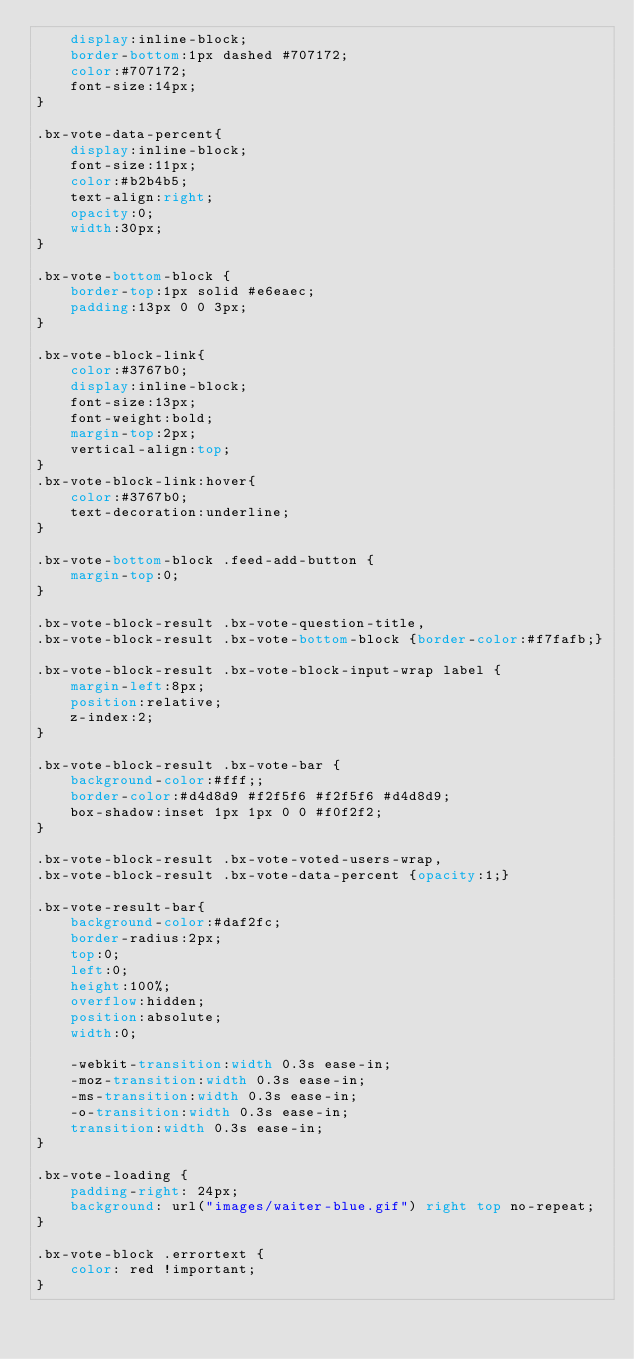<code> <loc_0><loc_0><loc_500><loc_500><_CSS_>	display:inline-block;
	border-bottom:1px dashed #707172;
	color:#707172;
	font-size:14px;
}

.bx-vote-data-percent{
	display:inline-block;
	font-size:11px;
	color:#b2b4b5;
	text-align:right;
	opacity:0;
	width:30px;
}

.bx-vote-bottom-block {
	border-top:1px solid #e6eaec;
	padding:13px 0 0 3px;
}

.bx-vote-block-link{
	color:#3767b0;
	display:inline-block;
	font-size:13px;
	font-weight:bold;
	margin-top:2px;
	vertical-align:top;
}
.bx-vote-block-link:hover{
	color:#3767b0;
	text-decoration:underline;
}

.bx-vote-bottom-block .feed-add-button {
	margin-top:0;
}

.bx-vote-block-result .bx-vote-question-title,
.bx-vote-block-result .bx-vote-bottom-block {border-color:#f7fafb;}

.bx-vote-block-result .bx-vote-block-input-wrap label {
	margin-left:8px;
	position:relative;
	z-index:2;
}

.bx-vote-block-result .bx-vote-bar {
	background-color:#fff;;
	border-color:#d4d8d9 #f2f5f6 #f2f5f6 #d4d8d9;
	box-shadow:inset 1px 1px 0 0 #f0f2f2;
}

.bx-vote-block-result .bx-vote-voted-users-wrap,
.bx-vote-block-result .bx-vote-data-percent {opacity:1;}

.bx-vote-result-bar{
	background-color:#daf2fc;
	border-radius:2px;
	top:0;
	left:0;
	height:100%;
	overflow:hidden;
	position:absolute;
	width:0;

	-webkit-transition:width 0.3s ease-in;
	-moz-transition:width 0.3s ease-in;
	-ms-transition:width 0.3s ease-in;
	-o-transition:width 0.3s ease-in;
	transition:width 0.3s ease-in;
}

.bx-vote-loading {
	padding-right: 24px;
	background: url("images/waiter-blue.gif") right top no-repeat;
}

.bx-vote-block .errortext {
	color: red !important;
}</code> 